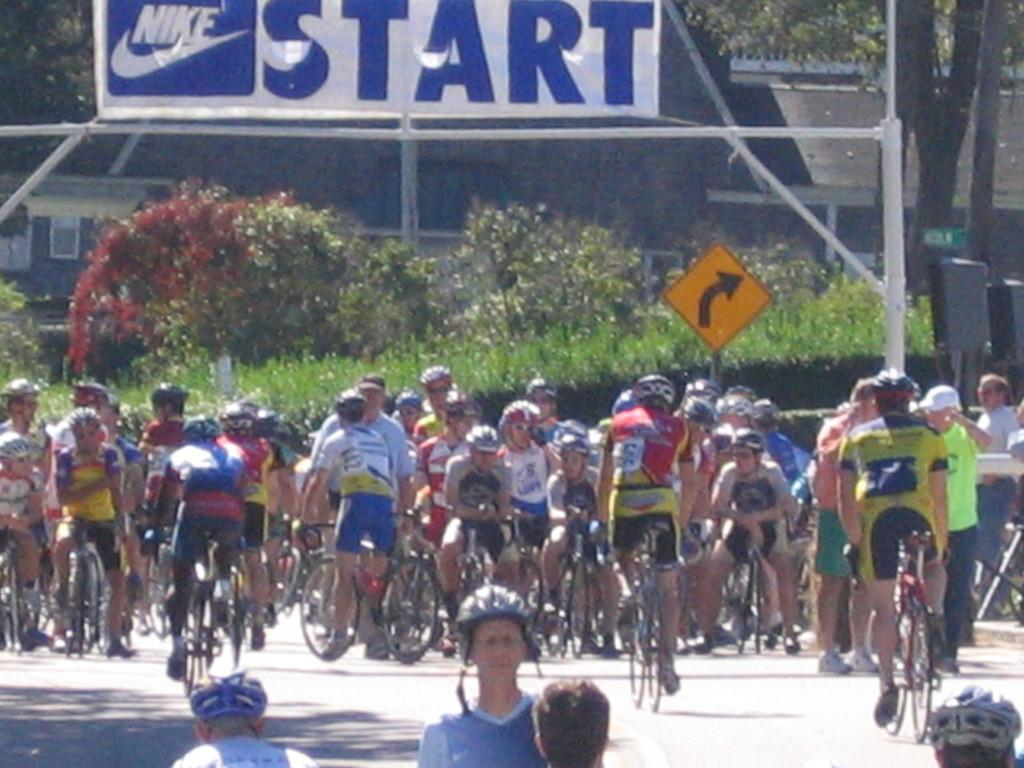How many people are in the image? There are multiple persons in the image. What are the persons doing in the image? The persons are riding cycles. What can be seen in the background of the image? There are trees in the background of the image. How would you describe the environment in the background? The background has greenery. What type of rice can be seen growing in the background of the image? There is no rice visible in the image; the background features trees and greenery. Can you spot an owl perched on one of the trees in the image? There is no owl present in the image; only trees and greenery are visible in the background. 